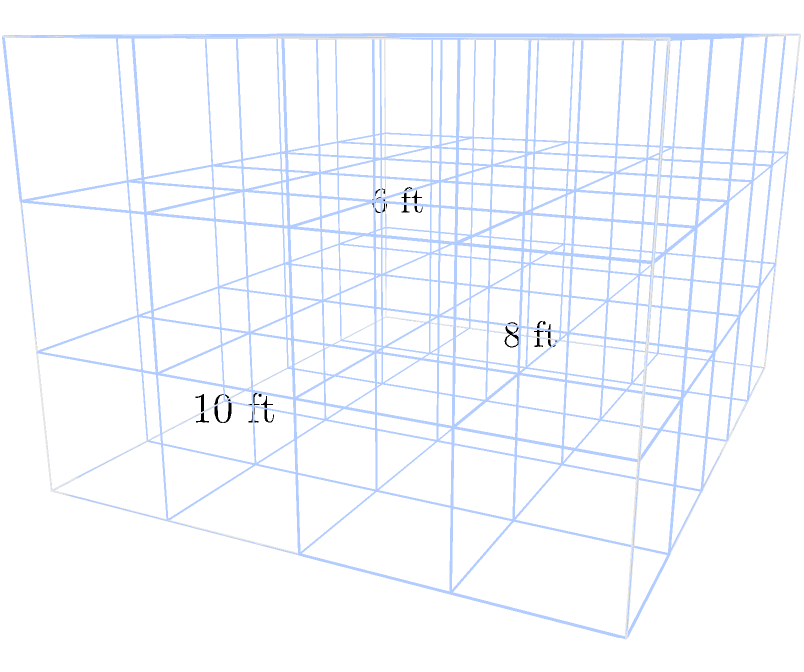As a stay-at-home dad setting up a home office, you want to optimize storage space using cube-shaped boxes. Your office measures 10 feet long, 8 feet wide, and 6 feet high. If each storage box is a 2-foot cube, what is the maximum number of boxes you can fit in the room without stacking them higher than 6 feet? Let's approach this step-by-step:

1) First, we need to determine how many boxes can fit along each dimension:

   Length: $10 \text{ ft} \div 2 \text{ ft} = 5$ boxes
   Width: $8 \text{ ft} \div 2 \text{ ft} = 4$ boxes
   Height: $6 \text{ ft} \div 2 \text{ ft} = 3$ boxes

2) Now, we can calculate the total number of boxes by multiplying these values:

   $\text{Total boxes} = 5 \times 4 \times 3 = 60$

3) This arrangement fully utilizes the available space without exceeding the 6-foot height limit.

4) It's worth noting that this solution assumes you want to maximize the use of vertical space. If you prefer fewer stacks for easier access, you could use fewer boxes, but 60 is the maximum that fits the given constraints.

5) This layout also leaves no extra space, which is ideal for maximizing storage but may not be practical for movement. In a real-world scenario, you might want to leave some space for accessing the boxes or moving around the room.
Answer: 60 boxes 